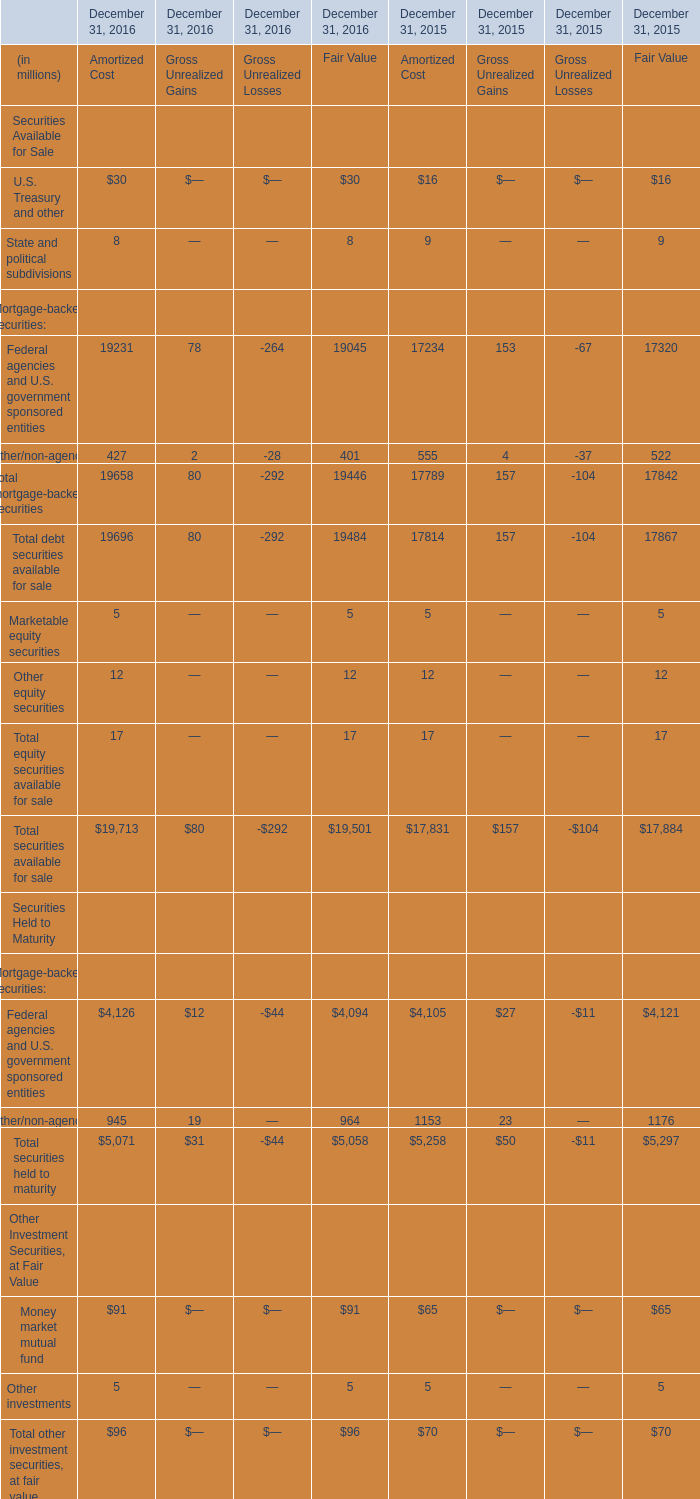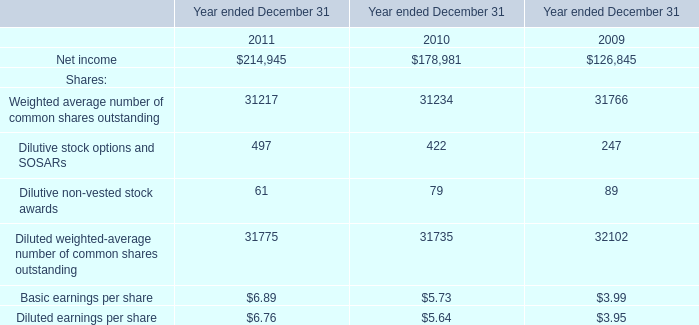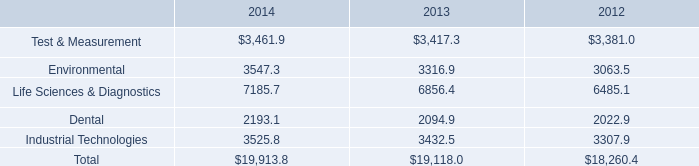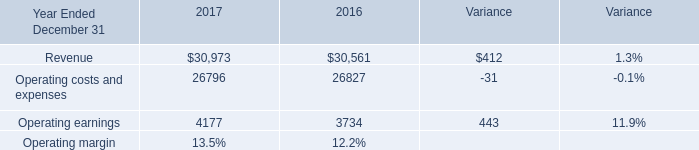What's the 50 % of total Federal agencies and U.S. government sponsored entities in 2016? (in million) 
Computations: ((((19231 + 78) + -264) + 19045) * 0.5)
Answer: 19045.0. 